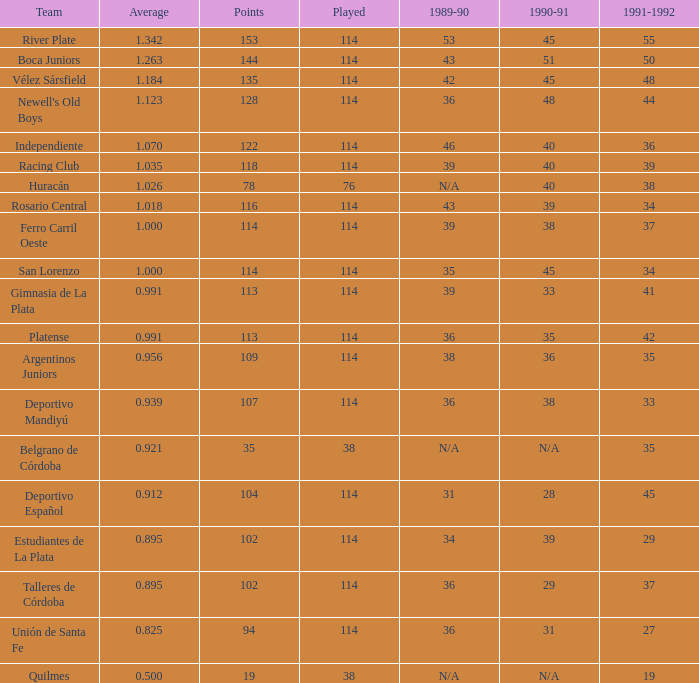How many instances of played have an average below 0.9390000000000001 and a 1990-91 figure of 28? 1.0. 